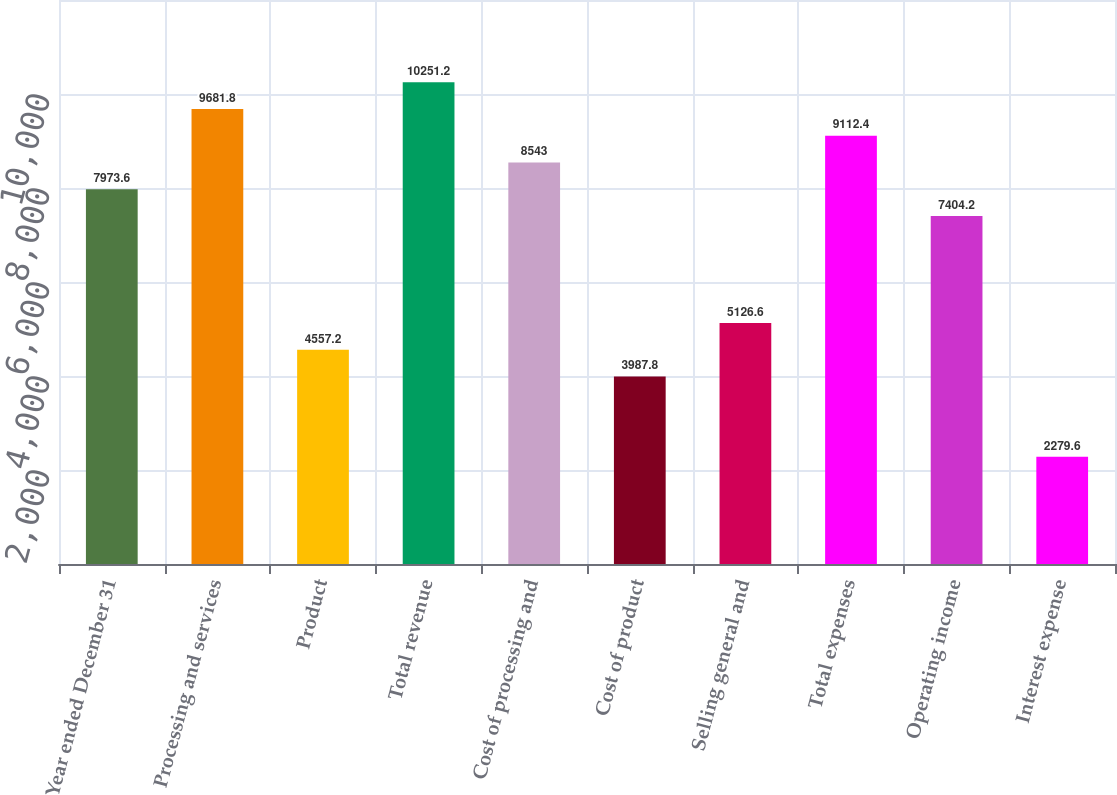Convert chart to OTSL. <chart><loc_0><loc_0><loc_500><loc_500><bar_chart><fcel>Year ended December 31<fcel>Processing and services<fcel>Product<fcel>Total revenue<fcel>Cost of processing and<fcel>Cost of product<fcel>Selling general and<fcel>Total expenses<fcel>Operating income<fcel>Interest expense<nl><fcel>7973.6<fcel>9681.8<fcel>4557.2<fcel>10251.2<fcel>8543<fcel>3987.8<fcel>5126.6<fcel>9112.4<fcel>7404.2<fcel>2279.6<nl></chart> 